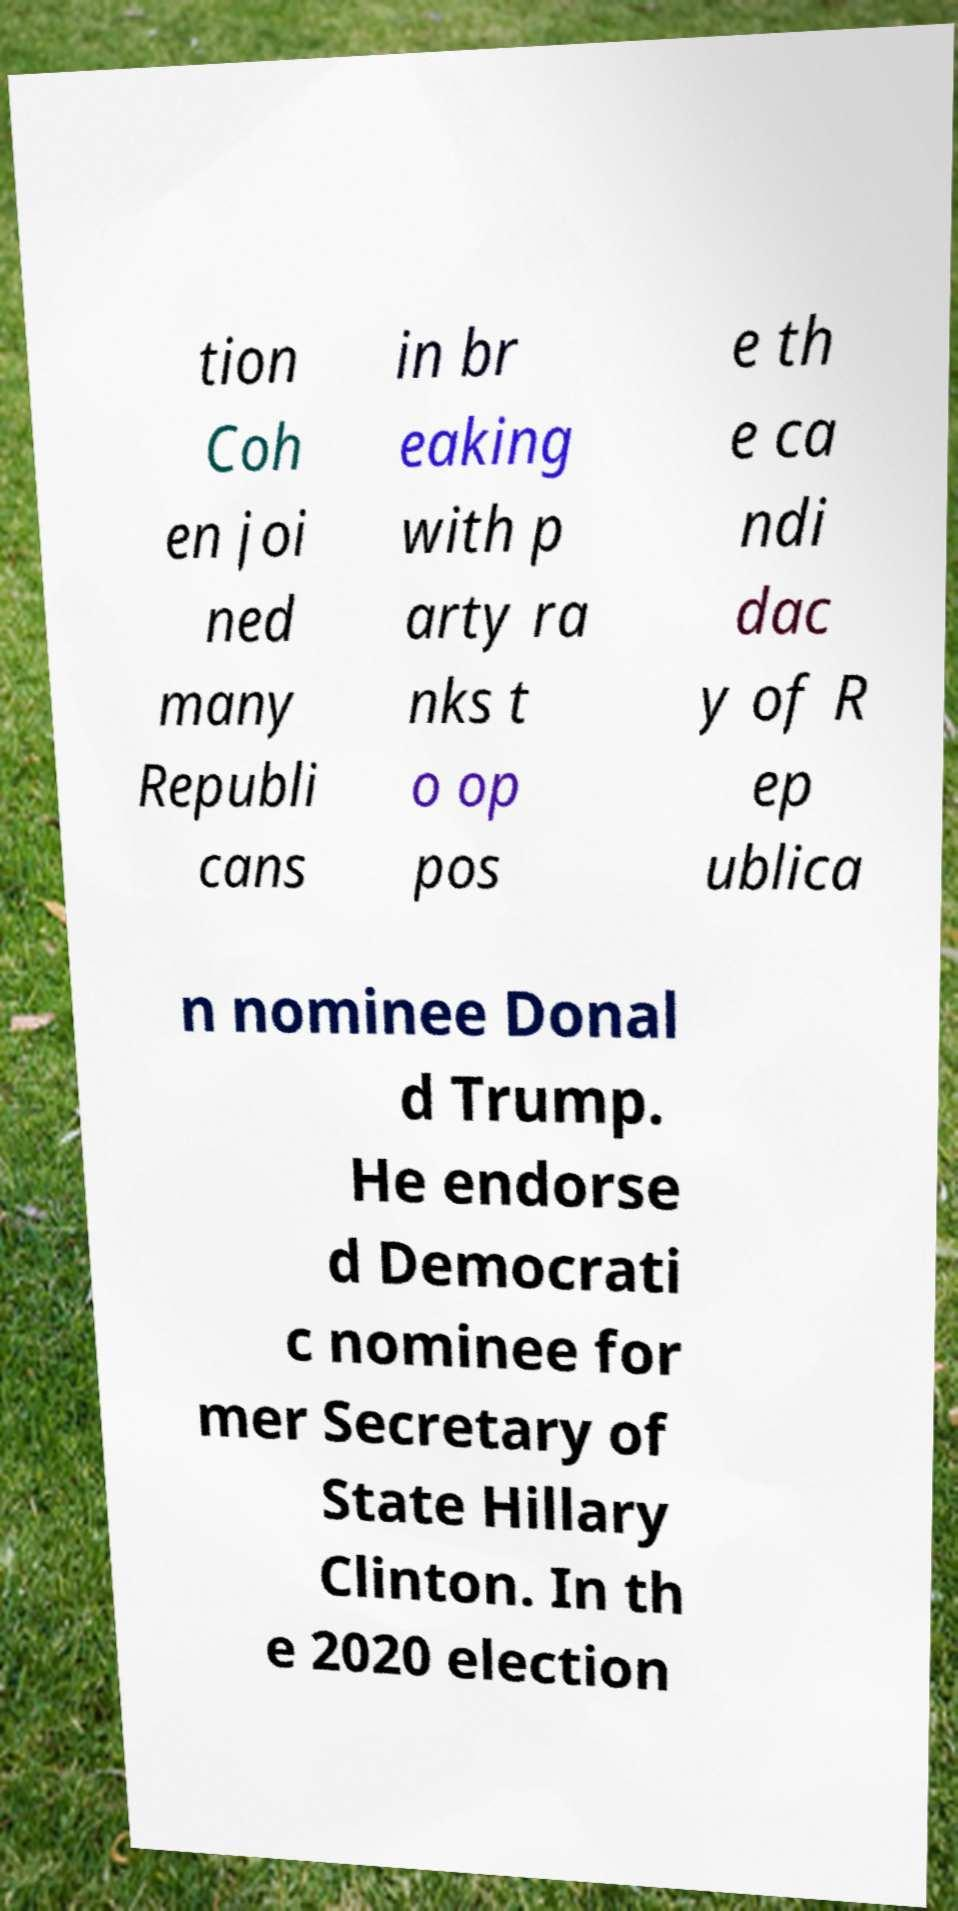Please read and relay the text visible in this image. What does it say? tion Coh en joi ned many Republi cans in br eaking with p arty ra nks t o op pos e th e ca ndi dac y of R ep ublica n nominee Donal d Trump. He endorse d Democrati c nominee for mer Secretary of State Hillary Clinton. In th e 2020 election 